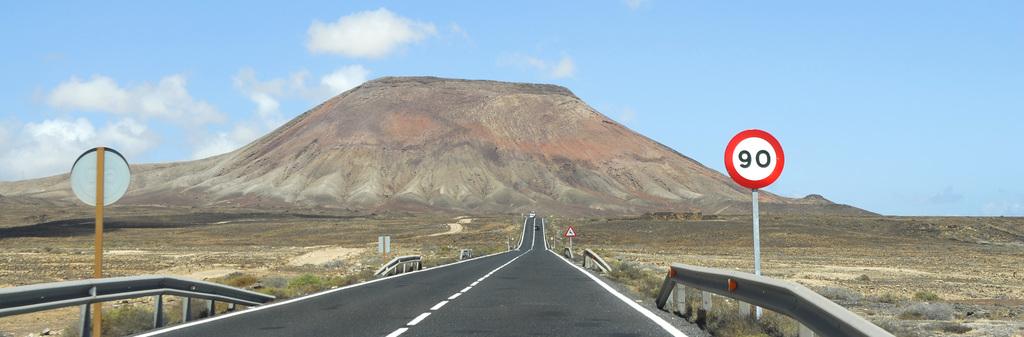What is the speed limit of this road?
Ensure brevity in your answer.  90. What is the first number on the sign?
Offer a very short reply. 9. 